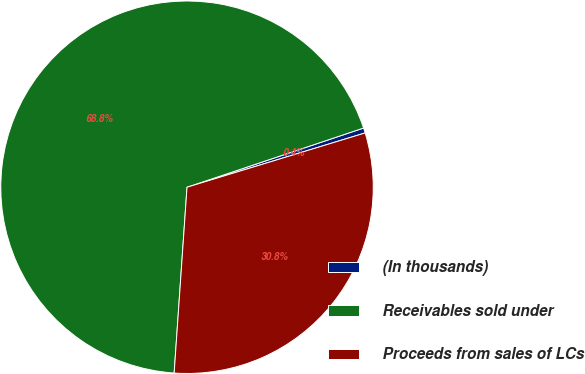<chart> <loc_0><loc_0><loc_500><loc_500><pie_chart><fcel>(In thousands)<fcel>Receivables sold under<fcel>Proceeds from sales of LCs<nl><fcel>0.44%<fcel>68.75%<fcel>30.81%<nl></chart> 